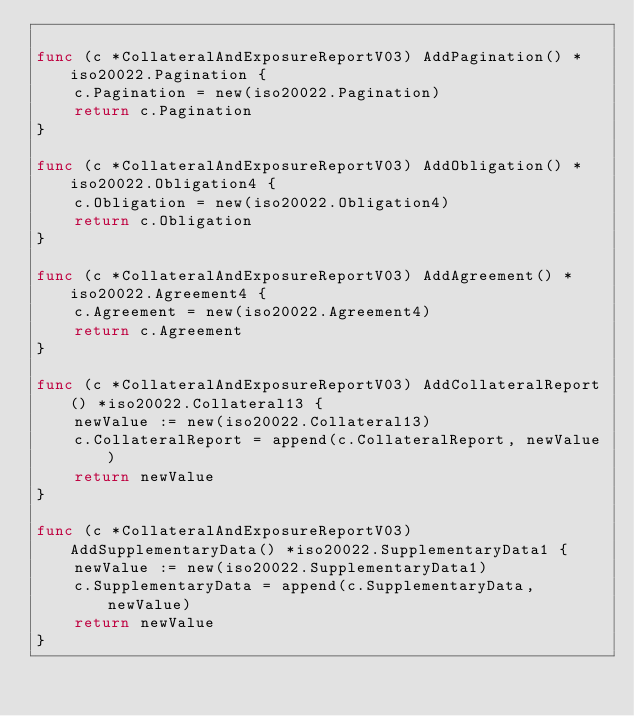<code> <loc_0><loc_0><loc_500><loc_500><_Go_>
func (c *CollateralAndExposureReportV03) AddPagination() *iso20022.Pagination {
	c.Pagination = new(iso20022.Pagination)
	return c.Pagination
}

func (c *CollateralAndExposureReportV03) AddObligation() *iso20022.Obligation4 {
	c.Obligation = new(iso20022.Obligation4)
	return c.Obligation
}

func (c *CollateralAndExposureReportV03) AddAgreement() *iso20022.Agreement4 {
	c.Agreement = new(iso20022.Agreement4)
	return c.Agreement
}

func (c *CollateralAndExposureReportV03) AddCollateralReport() *iso20022.Collateral13 {
	newValue := new(iso20022.Collateral13)
	c.CollateralReport = append(c.CollateralReport, newValue)
	return newValue
}

func (c *CollateralAndExposureReportV03) AddSupplementaryData() *iso20022.SupplementaryData1 {
	newValue := new(iso20022.SupplementaryData1)
	c.SupplementaryData = append(c.SupplementaryData, newValue)
	return newValue
}
</code> 